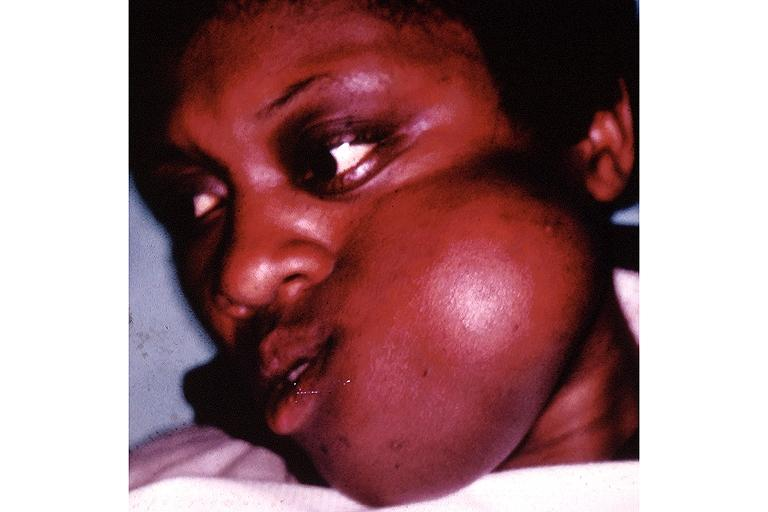where is this?
Answer the question using a single word or phrase. Oral 